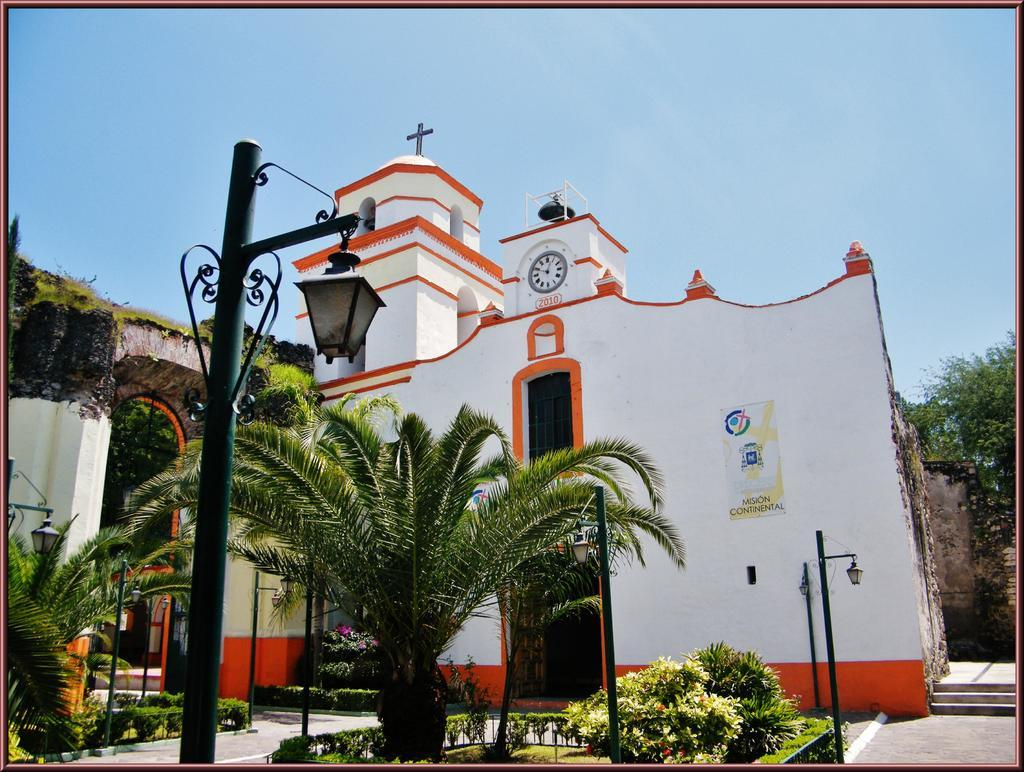What type of structures can be seen in the image? There are buildings in the image. What other natural elements are present in the image? There are trees in the image. What are the vertical structures in the image used for? There are poles and light poles in the image, which are likely used for support and illumination. Can you describe a specific feature of one of the buildings? There is a window in the image, which is a feature of the building. What time-related object is visible in the image? There is a clock in the image. What is the color of the sky in the image? The sky is white and blue in color. Who is the creator of the plot in the image? There is no plot present in the image, as it is a scene featuring buildings, trees, poles, light poles, a window, a clock, and a sky. What authority figure can be seen in the image? There is no authority figure present in the image. 